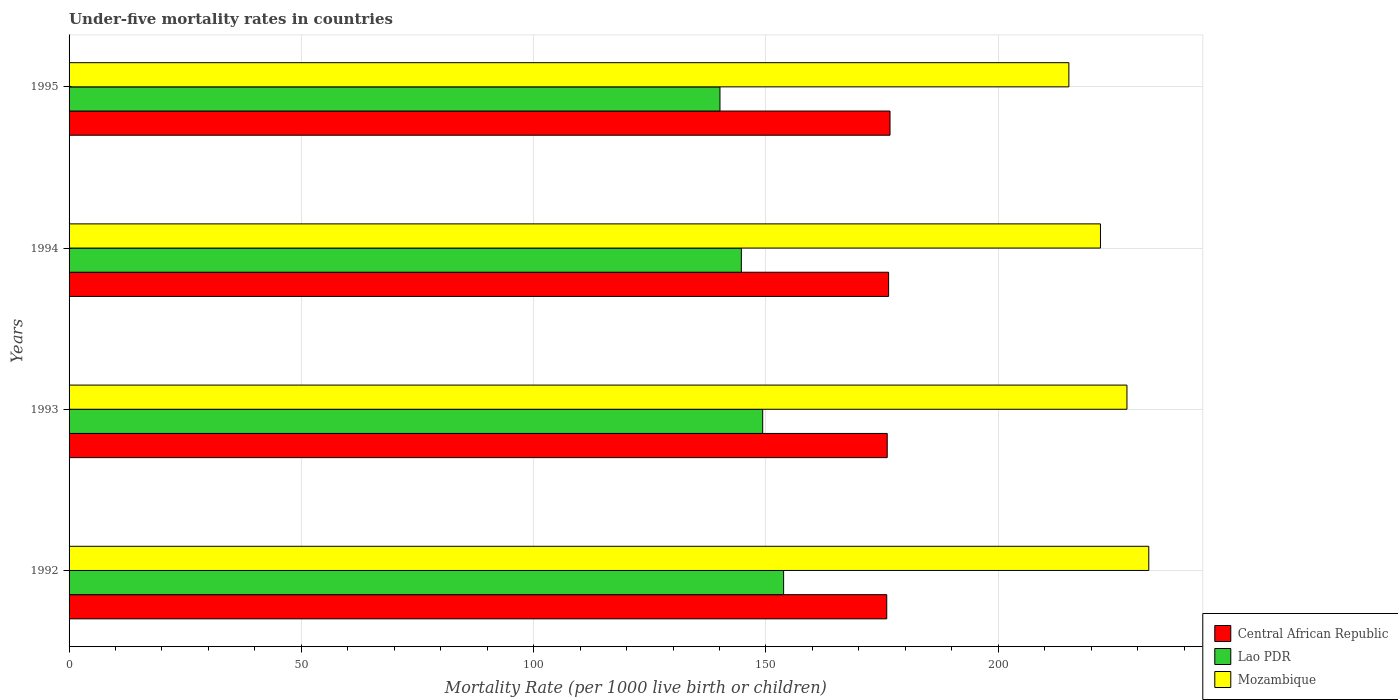Are the number of bars per tick equal to the number of legend labels?
Keep it short and to the point. Yes. Are the number of bars on each tick of the Y-axis equal?
Provide a short and direct response. Yes. How many bars are there on the 4th tick from the top?
Your answer should be compact. 3. How many bars are there on the 2nd tick from the bottom?
Make the answer very short. 3. What is the under-five mortality rate in Mozambique in 1992?
Provide a succinct answer. 232.4. Across all years, what is the maximum under-five mortality rate in Mozambique?
Offer a terse response. 232.4. Across all years, what is the minimum under-five mortality rate in Lao PDR?
Provide a short and direct response. 140.1. In which year was the under-five mortality rate in Lao PDR minimum?
Provide a succinct answer. 1995. What is the total under-five mortality rate in Central African Republic in the graph?
Give a very brief answer. 705.2. What is the difference between the under-five mortality rate in Mozambique in 1994 and that in 1995?
Your response must be concise. 6.8. What is the difference between the under-five mortality rate in Lao PDR in 1992 and the under-five mortality rate in Mozambique in 1993?
Offer a terse response. -73.9. What is the average under-five mortality rate in Lao PDR per year?
Your response must be concise. 146.97. In the year 1995, what is the difference between the under-five mortality rate in Mozambique and under-five mortality rate in Central African Republic?
Your answer should be compact. 38.5. What is the ratio of the under-five mortality rate in Mozambique in 1993 to that in 1994?
Your answer should be compact. 1.03. What is the difference between the highest and the second highest under-five mortality rate in Mozambique?
Offer a very short reply. 4.7. What is the difference between the highest and the lowest under-five mortality rate in Central African Republic?
Your answer should be compact. 0.7. In how many years, is the under-five mortality rate in Mozambique greater than the average under-five mortality rate in Mozambique taken over all years?
Offer a very short reply. 2. What does the 3rd bar from the top in 1992 represents?
Your answer should be compact. Central African Republic. What does the 2nd bar from the bottom in 1992 represents?
Ensure brevity in your answer.  Lao PDR. Is it the case that in every year, the sum of the under-five mortality rate in Lao PDR and under-five mortality rate in Mozambique is greater than the under-five mortality rate in Central African Republic?
Offer a very short reply. Yes. Does the graph contain any zero values?
Provide a succinct answer. No. Does the graph contain grids?
Your answer should be very brief. Yes. How many legend labels are there?
Your answer should be very brief. 3. How are the legend labels stacked?
Provide a succinct answer. Vertical. What is the title of the graph?
Provide a succinct answer. Under-five mortality rates in countries. Does "Croatia" appear as one of the legend labels in the graph?
Your answer should be very brief. No. What is the label or title of the X-axis?
Give a very brief answer. Mortality Rate (per 1000 live birth or children). What is the label or title of the Y-axis?
Keep it short and to the point. Years. What is the Mortality Rate (per 1000 live birth or children) in Central African Republic in 1992?
Give a very brief answer. 176. What is the Mortality Rate (per 1000 live birth or children) in Lao PDR in 1992?
Your response must be concise. 153.8. What is the Mortality Rate (per 1000 live birth or children) in Mozambique in 1992?
Offer a very short reply. 232.4. What is the Mortality Rate (per 1000 live birth or children) of Central African Republic in 1993?
Your answer should be compact. 176.1. What is the Mortality Rate (per 1000 live birth or children) in Lao PDR in 1993?
Make the answer very short. 149.3. What is the Mortality Rate (per 1000 live birth or children) in Mozambique in 1993?
Ensure brevity in your answer.  227.7. What is the Mortality Rate (per 1000 live birth or children) of Central African Republic in 1994?
Provide a short and direct response. 176.4. What is the Mortality Rate (per 1000 live birth or children) in Lao PDR in 1994?
Make the answer very short. 144.7. What is the Mortality Rate (per 1000 live birth or children) of Mozambique in 1994?
Your answer should be very brief. 222. What is the Mortality Rate (per 1000 live birth or children) in Central African Republic in 1995?
Give a very brief answer. 176.7. What is the Mortality Rate (per 1000 live birth or children) of Lao PDR in 1995?
Your answer should be very brief. 140.1. What is the Mortality Rate (per 1000 live birth or children) of Mozambique in 1995?
Provide a short and direct response. 215.2. Across all years, what is the maximum Mortality Rate (per 1000 live birth or children) in Central African Republic?
Provide a succinct answer. 176.7. Across all years, what is the maximum Mortality Rate (per 1000 live birth or children) in Lao PDR?
Provide a succinct answer. 153.8. Across all years, what is the maximum Mortality Rate (per 1000 live birth or children) of Mozambique?
Ensure brevity in your answer.  232.4. Across all years, what is the minimum Mortality Rate (per 1000 live birth or children) in Central African Republic?
Provide a succinct answer. 176. Across all years, what is the minimum Mortality Rate (per 1000 live birth or children) in Lao PDR?
Your response must be concise. 140.1. Across all years, what is the minimum Mortality Rate (per 1000 live birth or children) of Mozambique?
Offer a very short reply. 215.2. What is the total Mortality Rate (per 1000 live birth or children) in Central African Republic in the graph?
Your response must be concise. 705.2. What is the total Mortality Rate (per 1000 live birth or children) of Lao PDR in the graph?
Offer a terse response. 587.9. What is the total Mortality Rate (per 1000 live birth or children) of Mozambique in the graph?
Offer a terse response. 897.3. What is the difference between the Mortality Rate (per 1000 live birth or children) of Central African Republic in 1992 and that in 1993?
Make the answer very short. -0.1. What is the difference between the Mortality Rate (per 1000 live birth or children) in Lao PDR in 1992 and that in 1993?
Give a very brief answer. 4.5. What is the difference between the Mortality Rate (per 1000 live birth or children) in Central African Republic in 1992 and that in 1995?
Provide a succinct answer. -0.7. What is the difference between the Mortality Rate (per 1000 live birth or children) in Central African Republic in 1993 and that in 1994?
Give a very brief answer. -0.3. What is the difference between the Mortality Rate (per 1000 live birth or children) in Lao PDR in 1993 and that in 1994?
Give a very brief answer. 4.6. What is the difference between the Mortality Rate (per 1000 live birth or children) in Central African Republic in 1994 and that in 1995?
Your response must be concise. -0.3. What is the difference between the Mortality Rate (per 1000 live birth or children) of Central African Republic in 1992 and the Mortality Rate (per 1000 live birth or children) of Lao PDR in 1993?
Your response must be concise. 26.7. What is the difference between the Mortality Rate (per 1000 live birth or children) of Central African Republic in 1992 and the Mortality Rate (per 1000 live birth or children) of Mozambique in 1993?
Ensure brevity in your answer.  -51.7. What is the difference between the Mortality Rate (per 1000 live birth or children) of Lao PDR in 1992 and the Mortality Rate (per 1000 live birth or children) of Mozambique in 1993?
Keep it short and to the point. -73.9. What is the difference between the Mortality Rate (per 1000 live birth or children) in Central African Republic in 1992 and the Mortality Rate (per 1000 live birth or children) in Lao PDR in 1994?
Provide a succinct answer. 31.3. What is the difference between the Mortality Rate (per 1000 live birth or children) in Central African Republic in 1992 and the Mortality Rate (per 1000 live birth or children) in Mozambique in 1994?
Your answer should be very brief. -46. What is the difference between the Mortality Rate (per 1000 live birth or children) of Lao PDR in 1992 and the Mortality Rate (per 1000 live birth or children) of Mozambique in 1994?
Keep it short and to the point. -68.2. What is the difference between the Mortality Rate (per 1000 live birth or children) in Central African Republic in 1992 and the Mortality Rate (per 1000 live birth or children) in Lao PDR in 1995?
Provide a short and direct response. 35.9. What is the difference between the Mortality Rate (per 1000 live birth or children) in Central African Republic in 1992 and the Mortality Rate (per 1000 live birth or children) in Mozambique in 1995?
Your response must be concise. -39.2. What is the difference between the Mortality Rate (per 1000 live birth or children) in Lao PDR in 1992 and the Mortality Rate (per 1000 live birth or children) in Mozambique in 1995?
Give a very brief answer. -61.4. What is the difference between the Mortality Rate (per 1000 live birth or children) of Central African Republic in 1993 and the Mortality Rate (per 1000 live birth or children) of Lao PDR in 1994?
Your response must be concise. 31.4. What is the difference between the Mortality Rate (per 1000 live birth or children) of Central African Republic in 1993 and the Mortality Rate (per 1000 live birth or children) of Mozambique in 1994?
Provide a succinct answer. -45.9. What is the difference between the Mortality Rate (per 1000 live birth or children) in Lao PDR in 1993 and the Mortality Rate (per 1000 live birth or children) in Mozambique in 1994?
Make the answer very short. -72.7. What is the difference between the Mortality Rate (per 1000 live birth or children) of Central African Republic in 1993 and the Mortality Rate (per 1000 live birth or children) of Mozambique in 1995?
Your answer should be compact. -39.1. What is the difference between the Mortality Rate (per 1000 live birth or children) of Lao PDR in 1993 and the Mortality Rate (per 1000 live birth or children) of Mozambique in 1995?
Offer a terse response. -65.9. What is the difference between the Mortality Rate (per 1000 live birth or children) in Central African Republic in 1994 and the Mortality Rate (per 1000 live birth or children) in Lao PDR in 1995?
Keep it short and to the point. 36.3. What is the difference between the Mortality Rate (per 1000 live birth or children) in Central African Republic in 1994 and the Mortality Rate (per 1000 live birth or children) in Mozambique in 1995?
Provide a short and direct response. -38.8. What is the difference between the Mortality Rate (per 1000 live birth or children) of Lao PDR in 1994 and the Mortality Rate (per 1000 live birth or children) of Mozambique in 1995?
Your answer should be very brief. -70.5. What is the average Mortality Rate (per 1000 live birth or children) of Central African Republic per year?
Ensure brevity in your answer.  176.3. What is the average Mortality Rate (per 1000 live birth or children) in Lao PDR per year?
Your answer should be compact. 146.97. What is the average Mortality Rate (per 1000 live birth or children) in Mozambique per year?
Make the answer very short. 224.32. In the year 1992, what is the difference between the Mortality Rate (per 1000 live birth or children) in Central African Republic and Mortality Rate (per 1000 live birth or children) in Lao PDR?
Your answer should be very brief. 22.2. In the year 1992, what is the difference between the Mortality Rate (per 1000 live birth or children) in Central African Republic and Mortality Rate (per 1000 live birth or children) in Mozambique?
Your response must be concise. -56.4. In the year 1992, what is the difference between the Mortality Rate (per 1000 live birth or children) of Lao PDR and Mortality Rate (per 1000 live birth or children) of Mozambique?
Offer a terse response. -78.6. In the year 1993, what is the difference between the Mortality Rate (per 1000 live birth or children) in Central African Republic and Mortality Rate (per 1000 live birth or children) in Lao PDR?
Offer a terse response. 26.8. In the year 1993, what is the difference between the Mortality Rate (per 1000 live birth or children) in Central African Republic and Mortality Rate (per 1000 live birth or children) in Mozambique?
Provide a short and direct response. -51.6. In the year 1993, what is the difference between the Mortality Rate (per 1000 live birth or children) in Lao PDR and Mortality Rate (per 1000 live birth or children) in Mozambique?
Your answer should be compact. -78.4. In the year 1994, what is the difference between the Mortality Rate (per 1000 live birth or children) in Central African Republic and Mortality Rate (per 1000 live birth or children) in Lao PDR?
Your answer should be very brief. 31.7. In the year 1994, what is the difference between the Mortality Rate (per 1000 live birth or children) of Central African Republic and Mortality Rate (per 1000 live birth or children) of Mozambique?
Your answer should be compact. -45.6. In the year 1994, what is the difference between the Mortality Rate (per 1000 live birth or children) of Lao PDR and Mortality Rate (per 1000 live birth or children) of Mozambique?
Ensure brevity in your answer.  -77.3. In the year 1995, what is the difference between the Mortality Rate (per 1000 live birth or children) of Central African Republic and Mortality Rate (per 1000 live birth or children) of Lao PDR?
Your answer should be compact. 36.6. In the year 1995, what is the difference between the Mortality Rate (per 1000 live birth or children) in Central African Republic and Mortality Rate (per 1000 live birth or children) in Mozambique?
Keep it short and to the point. -38.5. In the year 1995, what is the difference between the Mortality Rate (per 1000 live birth or children) in Lao PDR and Mortality Rate (per 1000 live birth or children) in Mozambique?
Your response must be concise. -75.1. What is the ratio of the Mortality Rate (per 1000 live birth or children) of Central African Republic in 1992 to that in 1993?
Offer a very short reply. 1. What is the ratio of the Mortality Rate (per 1000 live birth or children) in Lao PDR in 1992 to that in 1993?
Give a very brief answer. 1.03. What is the ratio of the Mortality Rate (per 1000 live birth or children) in Mozambique in 1992 to that in 1993?
Your answer should be compact. 1.02. What is the ratio of the Mortality Rate (per 1000 live birth or children) in Lao PDR in 1992 to that in 1994?
Make the answer very short. 1.06. What is the ratio of the Mortality Rate (per 1000 live birth or children) of Mozambique in 1992 to that in 1994?
Make the answer very short. 1.05. What is the ratio of the Mortality Rate (per 1000 live birth or children) in Lao PDR in 1992 to that in 1995?
Your answer should be very brief. 1.1. What is the ratio of the Mortality Rate (per 1000 live birth or children) in Mozambique in 1992 to that in 1995?
Offer a very short reply. 1.08. What is the ratio of the Mortality Rate (per 1000 live birth or children) of Lao PDR in 1993 to that in 1994?
Your response must be concise. 1.03. What is the ratio of the Mortality Rate (per 1000 live birth or children) in Mozambique in 1993 to that in 1994?
Make the answer very short. 1.03. What is the ratio of the Mortality Rate (per 1000 live birth or children) of Central African Republic in 1993 to that in 1995?
Ensure brevity in your answer.  1. What is the ratio of the Mortality Rate (per 1000 live birth or children) in Lao PDR in 1993 to that in 1995?
Your answer should be very brief. 1.07. What is the ratio of the Mortality Rate (per 1000 live birth or children) in Mozambique in 1993 to that in 1995?
Provide a succinct answer. 1.06. What is the ratio of the Mortality Rate (per 1000 live birth or children) of Central African Republic in 1994 to that in 1995?
Ensure brevity in your answer.  1. What is the ratio of the Mortality Rate (per 1000 live birth or children) of Lao PDR in 1994 to that in 1995?
Keep it short and to the point. 1.03. What is the ratio of the Mortality Rate (per 1000 live birth or children) in Mozambique in 1994 to that in 1995?
Give a very brief answer. 1.03. What is the difference between the highest and the second highest Mortality Rate (per 1000 live birth or children) in Lao PDR?
Your response must be concise. 4.5. What is the difference between the highest and the lowest Mortality Rate (per 1000 live birth or children) in Lao PDR?
Ensure brevity in your answer.  13.7. 